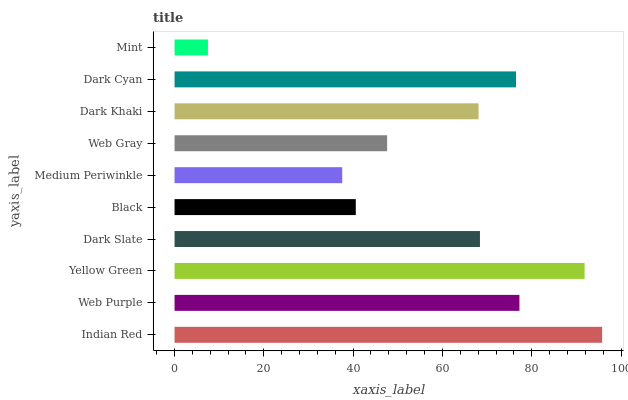Is Mint the minimum?
Answer yes or no. Yes. Is Indian Red the maximum?
Answer yes or no. Yes. Is Web Purple the minimum?
Answer yes or no. No. Is Web Purple the maximum?
Answer yes or no. No. Is Indian Red greater than Web Purple?
Answer yes or no. Yes. Is Web Purple less than Indian Red?
Answer yes or no. Yes. Is Web Purple greater than Indian Red?
Answer yes or no. No. Is Indian Red less than Web Purple?
Answer yes or no. No. Is Dark Slate the high median?
Answer yes or no. Yes. Is Dark Khaki the low median?
Answer yes or no. Yes. Is Medium Periwinkle the high median?
Answer yes or no. No. Is Black the low median?
Answer yes or no. No. 